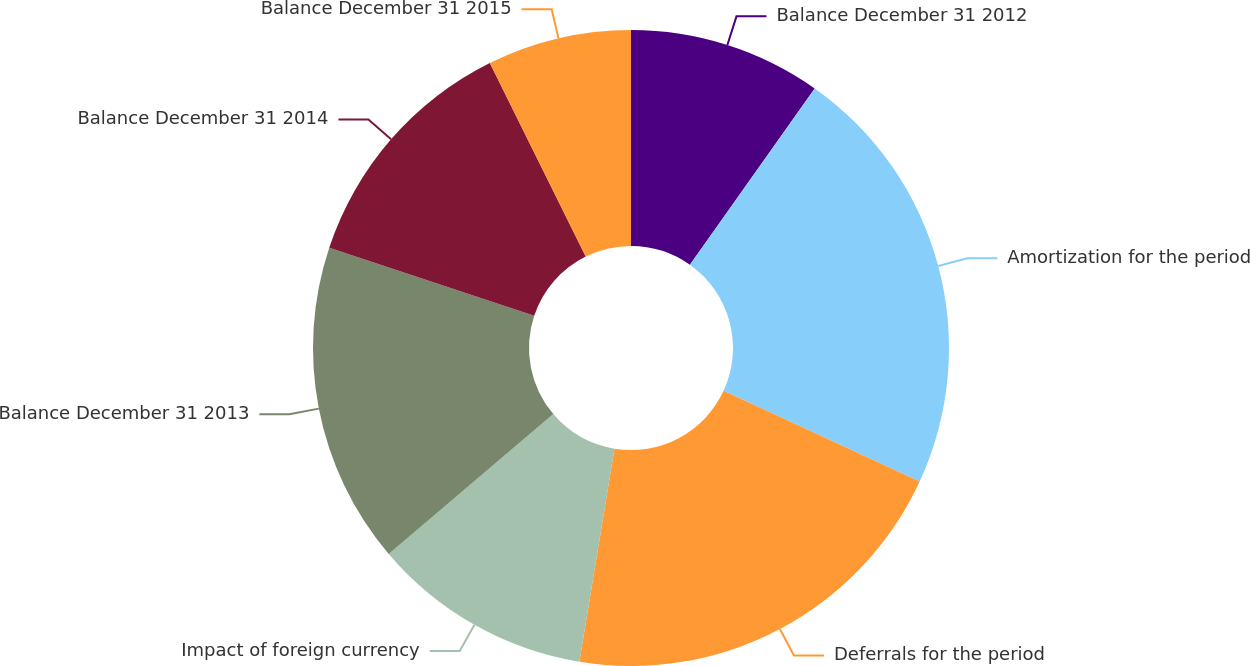Convert chart to OTSL. <chart><loc_0><loc_0><loc_500><loc_500><pie_chart><fcel>Balance December 31 2012<fcel>Amortization for the period<fcel>Deferrals for the period<fcel>Impact of foreign currency<fcel>Balance December 31 2013<fcel>Balance December 31 2014<fcel>Balance December 31 2015<nl><fcel>9.8%<fcel>22.09%<fcel>20.7%<fcel>11.19%<fcel>16.32%<fcel>12.57%<fcel>7.32%<nl></chart> 